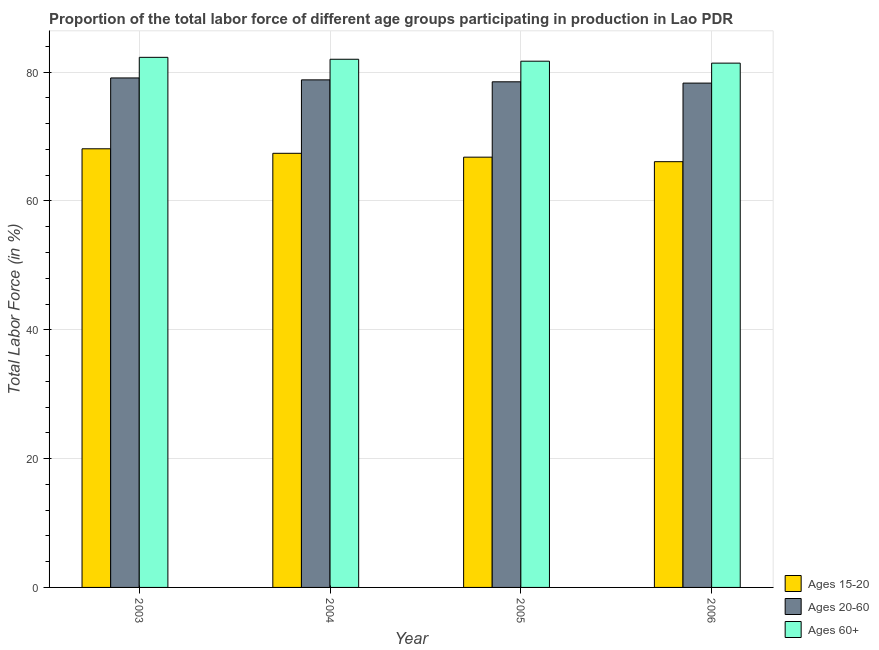How many different coloured bars are there?
Your answer should be compact. 3. How many bars are there on the 1st tick from the left?
Your response must be concise. 3. How many bars are there on the 3rd tick from the right?
Offer a terse response. 3. What is the label of the 2nd group of bars from the left?
Offer a terse response. 2004. In how many cases, is the number of bars for a given year not equal to the number of legend labels?
Offer a very short reply. 0. What is the percentage of labor force above age 60 in 2005?
Make the answer very short. 81.7. Across all years, what is the maximum percentage of labor force above age 60?
Provide a succinct answer. 82.3. Across all years, what is the minimum percentage of labor force within the age group 15-20?
Your answer should be compact. 66.1. In which year was the percentage of labor force above age 60 minimum?
Offer a very short reply. 2006. What is the total percentage of labor force within the age group 20-60 in the graph?
Ensure brevity in your answer.  314.7. What is the difference between the percentage of labor force above age 60 in 2006 and the percentage of labor force within the age group 15-20 in 2005?
Offer a very short reply. -0.3. What is the average percentage of labor force within the age group 20-60 per year?
Offer a terse response. 78.68. In how many years, is the percentage of labor force within the age group 20-60 greater than 68 %?
Provide a short and direct response. 4. What is the ratio of the percentage of labor force within the age group 15-20 in 2005 to that in 2006?
Offer a terse response. 1.01. What is the difference between the highest and the second highest percentage of labor force within the age group 15-20?
Provide a short and direct response. 0.7. In how many years, is the percentage of labor force within the age group 15-20 greater than the average percentage of labor force within the age group 15-20 taken over all years?
Offer a very short reply. 2. Is the sum of the percentage of labor force within the age group 15-20 in 2004 and 2006 greater than the maximum percentage of labor force above age 60 across all years?
Make the answer very short. Yes. What does the 1st bar from the left in 2006 represents?
Your response must be concise. Ages 15-20. What does the 1st bar from the right in 2005 represents?
Your response must be concise. Ages 60+. Is it the case that in every year, the sum of the percentage of labor force within the age group 15-20 and percentage of labor force within the age group 20-60 is greater than the percentage of labor force above age 60?
Provide a short and direct response. Yes. Are all the bars in the graph horizontal?
Ensure brevity in your answer.  No. How many years are there in the graph?
Offer a terse response. 4. What is the difference between two consecutive major ticks on the Y-axis?
Provide a short and direct response. 20. Does the graph contain any zero values?
Your answer should be very brief. No. Where does the legend appear in the graph?
Make the answer very short. Bottom right. How many legend labels are there?
Give a very brief answer. 3. What is the title of the graph?
Your answer should be very brief. Proportion of the total labor force of different age groups participating in production in Lao PDR. Does "Domestic" appear as one of the legend labels in the graph?
Provide a succinct answer. No. What is the label or title of the X-axis?
Your answer should be compact. Year. What is the Total Labor Force (in %) of Ages 15-20 in 2003?
Offer a terse response. 68.1. What is the Total Labor Force (in %) of Ages 20-60 in 2003?
Give a very brief answer. 79.1. What is the Total Labor Force (in %) in Ages 60+ in 2003?
Your answer should be very brief. 82.3. What is the Total Labor Force (in %) of Ages 15-20 in 2004?
Offer a very short reply. 67.4. What is the Total Labor Force (in %) of Ages 20-60 in 2004?
Provide a succinct answer. 78.8. What is the Total Labor Force (in %) in Ages 15-20 in 2005?
Ensure brevity in your answer.  66.8. What is the Total Labor Force (in %) in Ages 20-60 in 2005?
Make the answer very short. 78.5. What is the Total Labor Force (in %) in Ages 60+ in 2005?
Keep it short and to the point. 81.7. What is the Total Labor Force (in %) in Ages 15-20 in 2006?
Make the answer very short. 66.1. What is the Total Labor Force (in %) of Ages 20-60 in 2006?
Keep it short and to the point. 78.3. What is the Total Labor Force (in %) in Ages 60+ in 2006?
Give a very brief answer. 81.4. Across all years, what is the maximum Total Labor Force (in %) in Ages 15-20?
Provide a succinct answer. 68.1. Across all years, what is the maximum Total Labor Force (in %) in Ages 20-60?
Make the answer very short. 79.1. Across all years, what is the maximum Total Labor Force (in %) in Ages 60+?
Offer a terse response. 82.3. Across all years, what is the minimum Total Labor Force (in %) of Ages 15-20?
Ensure brevity in your answer.  66.1. Across all years, what is the minimum Total Labor Force (in %) in Ages 20-60?
Offer a terse response. 78.3. Across all years, what is the minimum Total Labor Force (in %) in Ages 60+?
Your response must be concise. 81.4. What is the total Total Labor Force (in %) in Ages 15-20 in the graph?
Give a very brief answer. 268.4. What is the total Total Labor Force (in %) in Ages 20-60 in the graph?
Keep it short and to the point. 314.7. What is the total Total Labor Force (in %) of Ages 60+ in the graph?
Make the answer very short. 327.4. What is the difference between the Total Labor Force (in %) in Ages 15-20 in 2003 and that in 2004?
Your response must be concise. 0.7. What is the difference between the Total Labor Force (in %) of Ages 20-60 in 2003 and that in 2004?
Offer a terse response. 0.3. What is the difference between the Total Labor Force (in %) of Ages 60+ in 2003 and that in 2005?
Offer a terse response. 0.6. What is the difference between the Total Labor Force (in %) of Ages 20-60 in 2004 and that in 2005?
Your answer should be very brief. 0.3. What is the difference between the Total Labor Force (in %) in Ages 20-60 in 2004 and that in 2006?
Your answer should be very brief. 0.5. What is the difference between the Total Labor Force (in %) in Ages 15-20 in 2005 and that in 2006?
Offer a terse response. 0.7. What is the difference between the Total Labor Force (in %) of Ages 15-20 in 2003 and the Total Labor Force (in %) of Ages 20-60 in 2004?
Keep it short and to the point. -10.7. What is the difference between the Total Labor Force (in %) in Ages 15-20 in 2003 and the Total Labor Force (in %) in Ages 60+ in 2004?
Provide a succinct answer. -13.9. What is the difference between the Total Labor Force (in %) in Ages 15-20 in 2003 and the Total Labor Force (in %) in Ages 20-60 in 2005?
Offer a very short reply. -10.4. What is the difference between the Total Labor Force (in %) in Ages 15-20 in 2003 and the Total Labor Force (in %) in Ages 60+ in 2005?
Make the answer very short. -13.6. What is the difference between the Total Labor Force (in %) in Ages 20-60 in 2003 and the Total Labor Force (in %) in Ages 60+ in 2005?
Provide a short and direct response. -2.6. What is the difference between the Total Labor Force (in %) of Ages 15-20 in 2003 and the Total Labor Force (in %) of Ages 20-60 in 2006?
Keep it short and to the point. -10.2. What is the difference between the Total Labor Force (in %) of Ages 20-60 in 2003 and the Total Labor Force (in %) of Ages 60+ in 2006?
Provide a succinct answer. -2.3. What is the difference between the Total Labor Force (in %) of Ages 15-20 in 2004 and the Total Labor Force (in %) of Ages 60+ in 2005?
Your answer should be very brief. -14.3. What is the difference between the Total Labor Force (in %) of Ages 20-60 in 2004 and the Total Labor Force (in %) of Ages 60+ in 2005?
Keep it short and to the point. -2.9. What is the difference between the Total Labor Force (in %) in Ages 20-60 in 2004 and the Total Labor Force (in %) in Ages 60+ in 2006?
Offer a very short reply. -2.6. What is the difference between the Total Labor Force (in %) of Ages 15-20 in 2005 and the Total Labor Force (in %) of Ages 60+ in 2006?
Keep it short and to the point. -14.6. What is the average Total Labor Force (in %) of Ages 15-20 per year?
Offer a terse response. 67.1. What is the average Total Labor Force (in %) of Ages 20-60 per year?
Provide a succinct answer. 78.67. What is the average Total Labor Force (in %) in Ages 60+ per year?
Provide a succinct answer. 81.85. In the year 2003, what is the difference between the Total Labor Force (in %) of Ages 15-20 and Total Labor Force (in %) of Ages 60+?
Make the answer very short. -14.2. In the year 2003, what is the difference between the Total Labor Force (in %) in Ages 20-60 and Total Labor Force (in %) in Ages 60+?
Provide a short and direct response. -3.2. In the year 2004, what is the difference between the Total Labor Force (in %) in Ages 15-20 and Total Labor Force (in %) in Ages 20-60?
Your answer should be very brief. -11.4. In the year 2004, what is the difference between the Total Labor Force (in %) in Ages 15-20 and Total Labor Force (in %) in Ages 60+?
Give a very brief answer. -14.6. In the year 2004, what is the difference between the Total Labor Force (in %) in Ages 20-60 and Total Labor Force (in %) in Ages 60+?
Ensure brevity in your answer.  -3.2. In the year 2005, what is the difference between the Total Labor Force (in %) of Ages 15-20 and Total Labor Force (in %) of Ages 60+?
Provide a short and direct response. -14.9. In the year 2005, what is the difference between the Total Labor Force (in %) in Ages 20-60 and Total Labor Force (in %) in Ages 60+?
Offer a terse response. -3.2. In the year 2006, what is the difference between the Total Labor Force (in %) in Ages 15-20 and Total Labor Force (in %) in Ages 60+?
Offer a terse response. -15.3. In the year 2006, what is the difference between the Total Labor Force (in %) in Ages 20-60 and Total Labor Force (in %) in Ages 60+?
Provide a short and direct response. -3.1. What is the ratio of the Total Labor Force (in %) in Ages 15-20 in 2003 to that in 2004?
Make the answer very short. 1.01. What is the ratio of the Total Labor Force (in %) in Ages 60+ in 2003 to that in 2004?
Provide a succinct answer. 1. What is the ratio of the Total Labor Force (in %) in Ages 15-20 in 2003 to that in 2005?
Give a very brief answer. 1.02. What is the ratio of the Total Labor Force (in %) in Ages 20-60 in 2003 to that in 2005?
Keep it short and to the point. 1.01. What is the ratio of the Total Labor Force (in %) in Ages 60+ in 2003 to that in 2005?
Provide a succinct answer. 1.01. What is the ratio of the Total Labor Force (in %) of Ages 15-20 in 2003 to that in 2006?
Your answer should be compact. 1.03. What is the ratio of the Total Labor Force (in %) in Ages 20-60 in 2003 to that in 2006?
Your response must be concise. 1.01. What is the ratio of the Total Labor Force (in %) of Ages 60+ in 2003 to that in 2006?
Your answer should be compact. 1.01. What is the ratio of the Total Labor Force (in %) of Ages 20-60 in 2004 to that in 2005?
Give a very brief answer. 1. What is the ratio of the Total Labor Force (in %) of Ages 15-20 in 2004 to that in 2006?
Your answer should be very brief. 1.02. What is the ratio of the Total Labor Force (in %) of Ages 20-60 in 2004 to that in 2006?
Provide a succinct answer. 1.01. What is the ratio of the Total Labor Force (in %) in Ages 60+ in 2004 to that in 2006?
Make the answer very short. 1.01. What is the ratio of the Total Labor Force (in %) of Ages 15-20 in 2005 to that in 2006?
Your response must be concise. 1.01. What is the ratio of the Total Labor Force (in %) of Ages 20-60 in 2005 to that in 2006?
Make the answer very short. 1. What is the ratio of the Total Labor Force (in %) of Ages 60+ in 2005 to that in 2006?
Ensure brevity in your answer.  1. What is the difference between the highest and the second highest Total Labor Force (in %) of Ages 15-20?
Your response must be concise. 0.7. What is the difference between the highest and the second highest Total Labor Force (in %) in Ages 20-60?
Give a very brief answer. 0.3. What is the difference between the highest and the lowest Total Labor Force (in %) in Ages 15-20?
Make the answer very short. 2. 